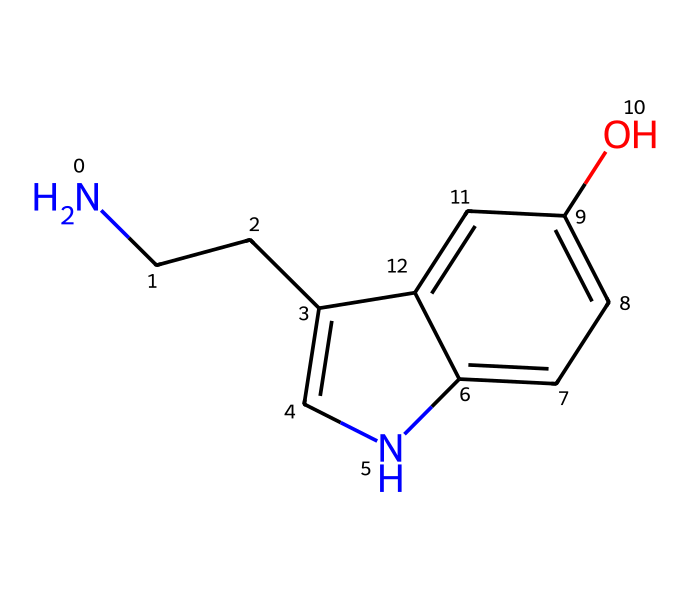What is the molecular formula of this chemical? To find the molecular formula, we need to count the atoms present in the structure: 10 carbon atoms, 12 hydrogen atoms, 1 nitrogen atom, and 1 oxygen atom, leading to the formula C10H12N2O.
Answer: C10H12N2O How many rings are present in this structure? By examining the structure, we can identify one fused ring system, which consists of two interconnected rings. Counting gives us a total of 2 rings.
Answer: 2 What type of functional group is present in this compound? The presence of a hydroxyl group (–OH) in the structure indicates that this compound is alcohol. This can be identified by observing the –OH attached to the benzene ring.
Answer: alcohol What is the primary element in this chemical structure? The structure has a dominant presence of carbon atoms, which are the backbone of the organic molecule. Therefore, carbon is the primary element.
Answer: carbon How many nitrogen atoms are present in this chemical? A careful count of the nitrogen atoms in the structure shows that there are 2 nitrogen atoms present in total, both of which significantly contribute to the compound's properties.
Answer: 2 What type of chemical is this based on its structure? Given that the structure contains an indole moiety (characterized by the fused benzene and pyrrole ring) and a side chain, it classifies the compound as a neurotransmitter and specifically serotonin.
Answer: neurotransmitter 